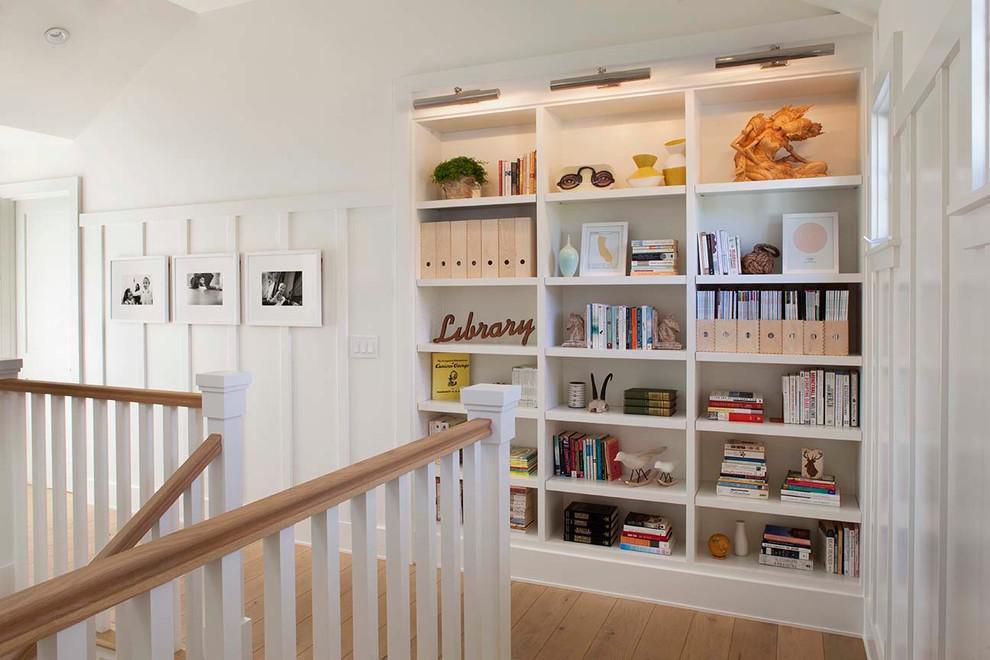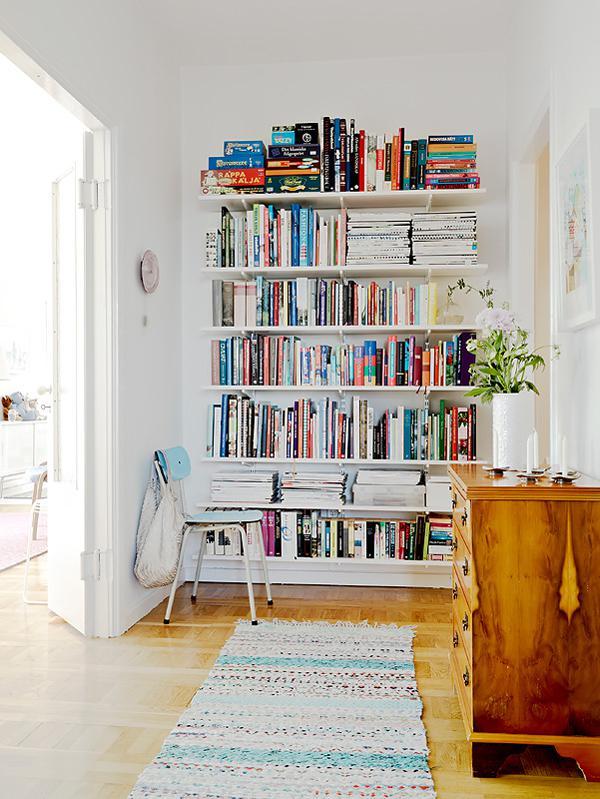The first image is the image on the left, the second image is the image on the right. Evaluate the accuracy of this statement regarding the images: "An image features a black upright corner shelf unit with items displayed on some of the shelves.". Is it true? Answer yes or no. No. The first image is the image on the left, the second image is the image on the right. Assess this claim about the two images: "In one image the shelves are black.". Correct or not? Answer yes or no. No. 